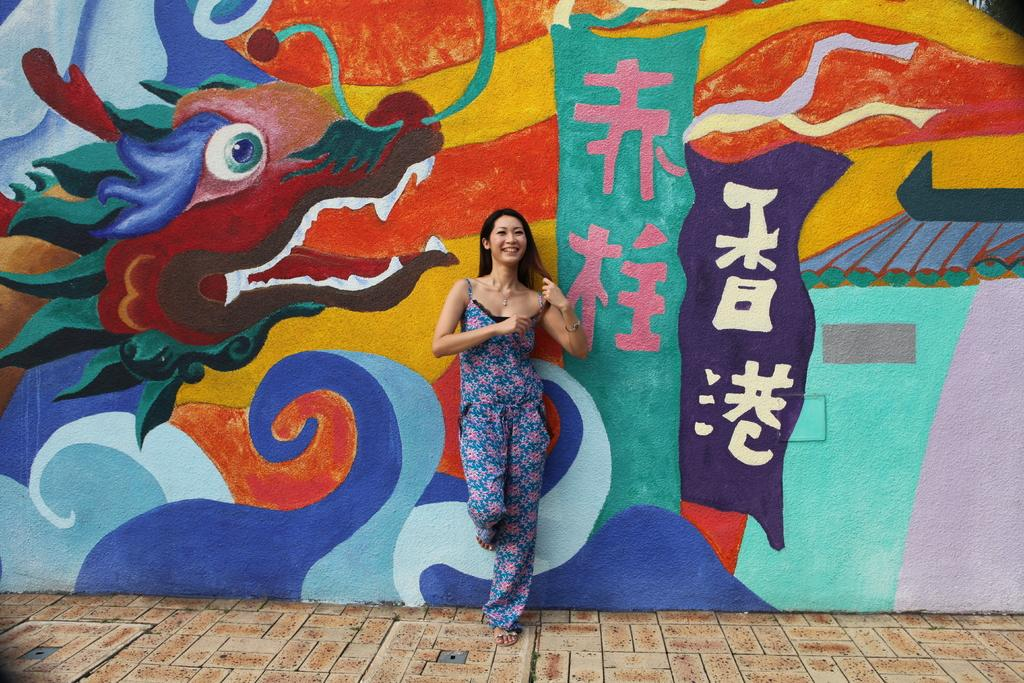What is the main subject of the image? There is a woman standing in the image. Where is the woman standing? The woman is standing on the floor. What is near the woman in the image? The woman is standing near a wall. What can be seen on the wall? There are paintings on the wall. What idea did the woman come up with during the week depicted in the image? There is no indication of time or any ideas in the image; it simply shows a woman standing near a wall with paintings on it. 